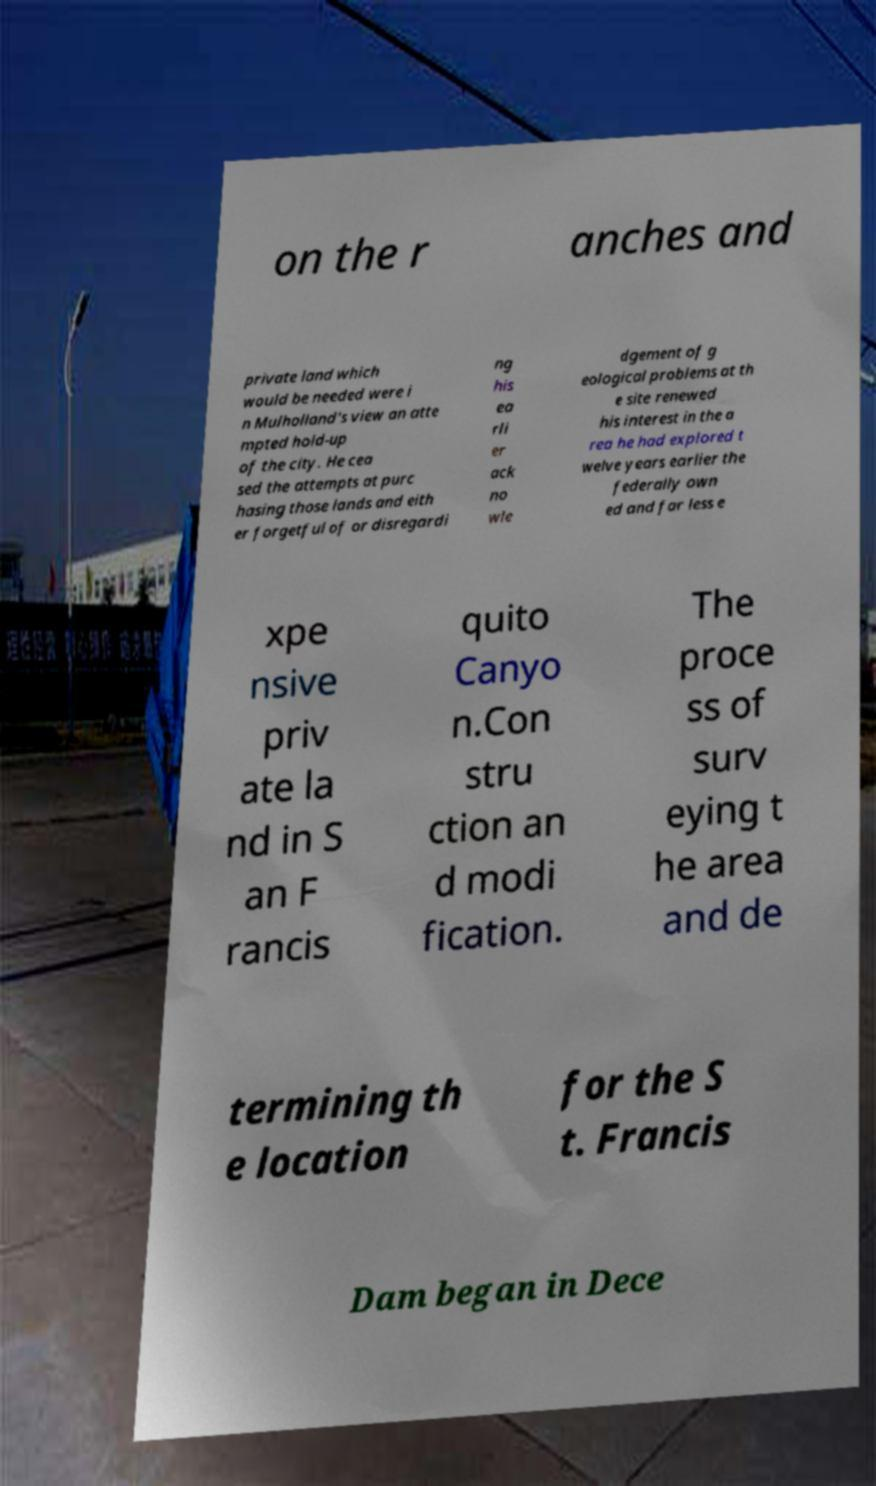Please identify and transcribe the text found in this image. on the r anches and private land which would be needed were i n Mulholland's view an atte mpted hold-up of the city. He cea sed the attempts at purc hasing those lands and eith er forgetful of or disregardi ng his ea rli er ack no wle dgement of g eological problems at th e site renewed his interest in the a rea he had explored t welve years earlier the federally own ed and far less e xpe nsive priv ate la nd in S an F rancis quito Canyo n.Con stru ction an d modi fication. The proce ss of surv eying t he area and de termining th e location for the S t. Francis Dam began in Dece 